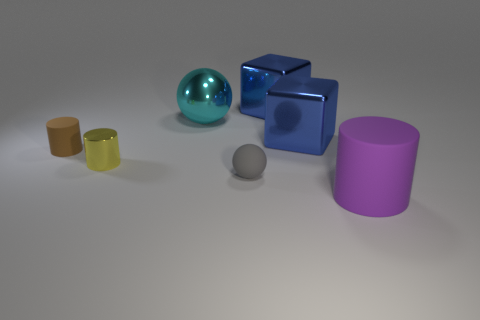Add 2 gray objects. How many objects exist? 9 Subtract all spheres. How many objects are left? 5 Subtract 0 brown blocks. How many objects are left? 7 Subtract all large balls. Subtract all large metallic things. How many objects are left? 3 Add 7 tiny matte objects. How many tiny matte objects are left? 9 Add 6 matte spheres. How many matte spheres exist? 7 